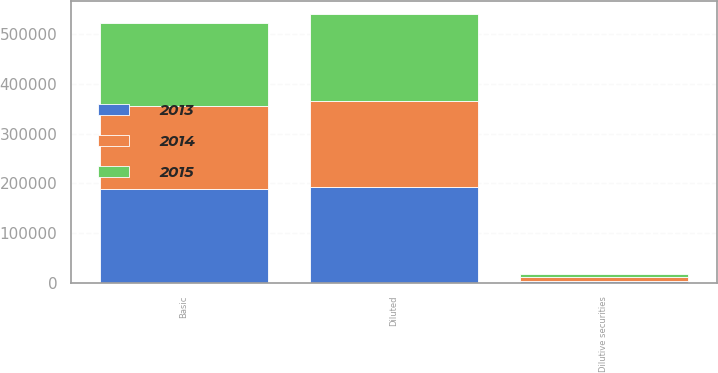<chart> <loc_0><loc_0><loc_500><loc_500><stacked_bar_chart><ecel><fcel>Basic<fcel>Dilutive securities<fcel>Diluted<nl><fcel>2013<fcel>188816<fcel>3770<fcel>192586<nl><fcel>2015<fcel>167257<fcel>7028<fcel>174285<nl><fcel>2014<fcel>166679<fcel>6708<fcel>173387<nl></chart> 